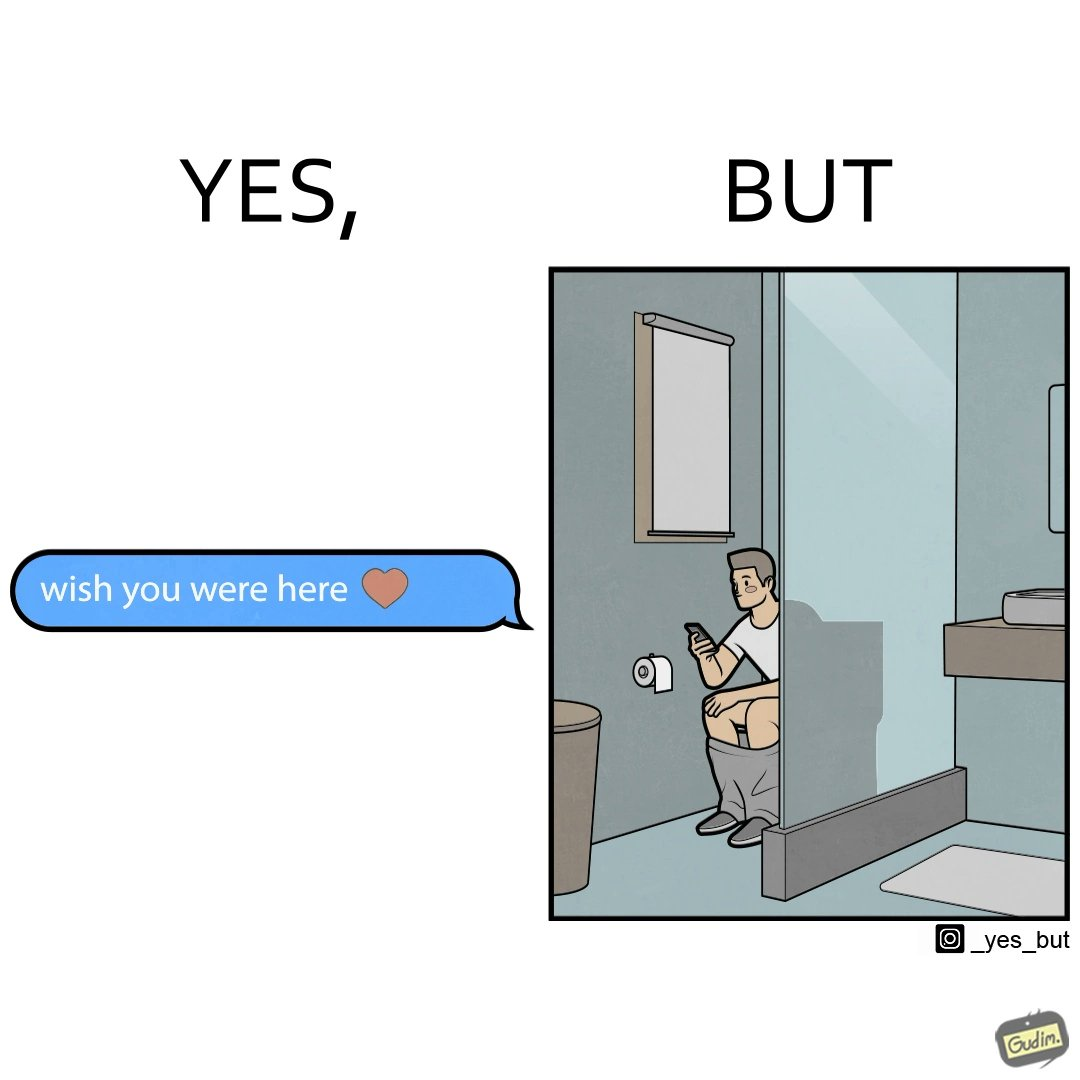Is this a satirical image? Yes, this image is satirical. 